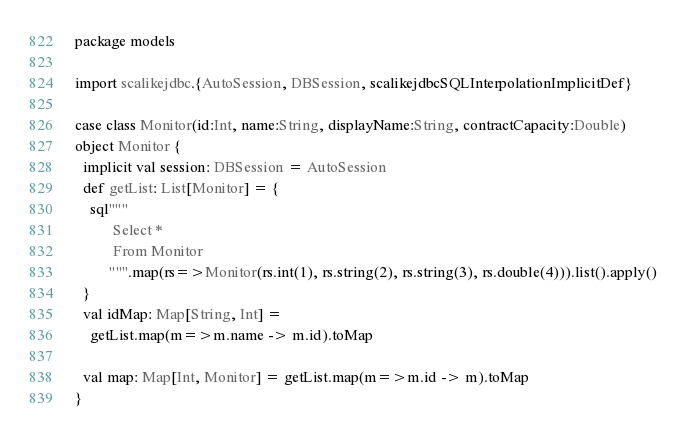<code> <loc_0><loc_0><loc_500><loc_500><_Scala_>package models

import scalikejdbc.{AutoSession, DBSession, scalikejdbcSQLInterpolationImplicitDef}

case class Monitor(id:Int, name:String, displayName:String, contractCapacity:Double)
object Monitor {
  implicit val session: DBSession = AutoSession
  def getList: List[Monitor] = {
    sql"""
          Select *
          From Monitor
         """.map(rs=>Monitor(rs.int(1), rs.string(2), rs.string(3), rs.double(4))).list().apply()
  }
  val idMap: Map[String, Int] =
    getList.map(m=>m.name -> m.id).toMap

  val map: Map[Int, Monitor] = getList.map(m=>m.id -> m).toMap
}
</code> 